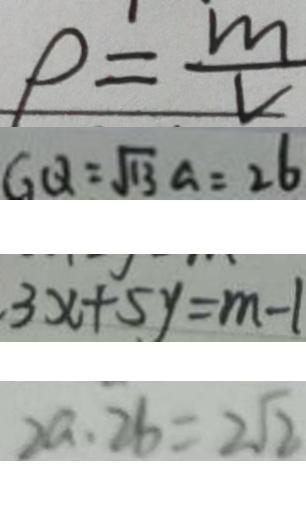Convert formula to latex. <formula><loc_0><loc_0><loc_500><loc_500>\rho = \frac { m } { v } 
 G Q = \sqrt { 1 3 } a = 2 6 
 3 x + 5 y = m - 1 
 2 a \cdot 2 b = 2 \sqrt { 2 }</formula> 